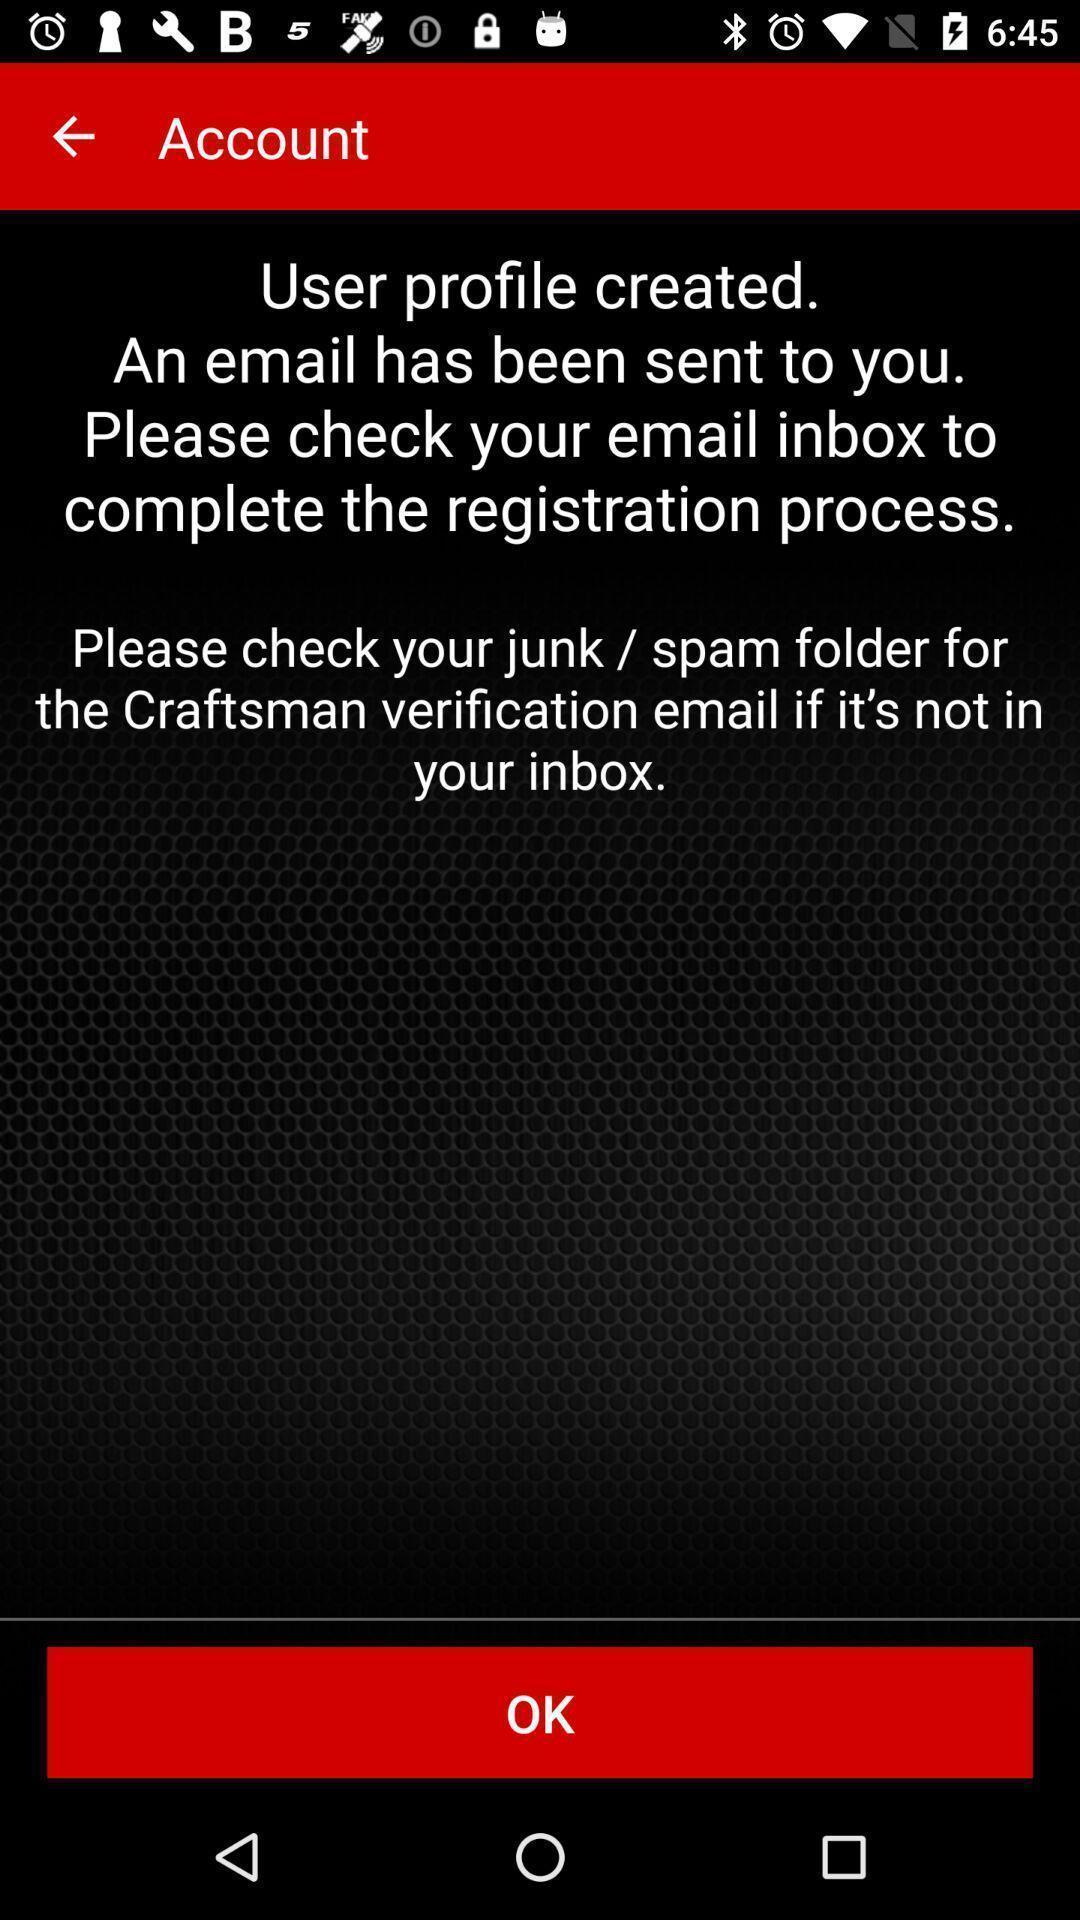Explain the elements present in this screenshot. Page showing an account has been created. 